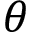<formula> <loc_0><loc_0><loc_500><loc_500>\theta</formula> 